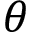<formula> <loc_0><loc_0><loc_500><loc_500>\theta</formula> 